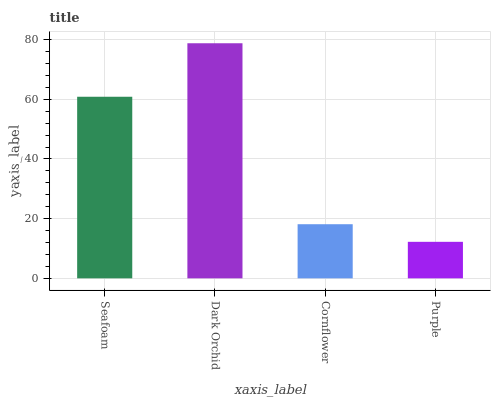Is Purple the minimum?
Answer yes or no. Yes. Is Dark Orchid the maximum?
Answer yes or no. Yes. Is Cornflower the minimum?
Answer yes or no. No. Is Cornflower the maximum?
Answer yes or no. No. Is Dark Orchid greater than Cornflower?
Answer yes or no. Yes. Is Cornflower less than Dark Orchid?
Answer yes or no. Yes. Is Cornflower greater than Dark Orchid?
Answer yes or no. No. Is Dark Orchid less than Cornflower?
Answer yes or no. No. Is Seafoam the high median?
Answer yes or no. Yes. Is Cornflower the low median?
Answer yes or no. Yes. Is Cornflower the high median?
Answer yes or no. No. Is Purple the low median?
Answer yes or no. No. 